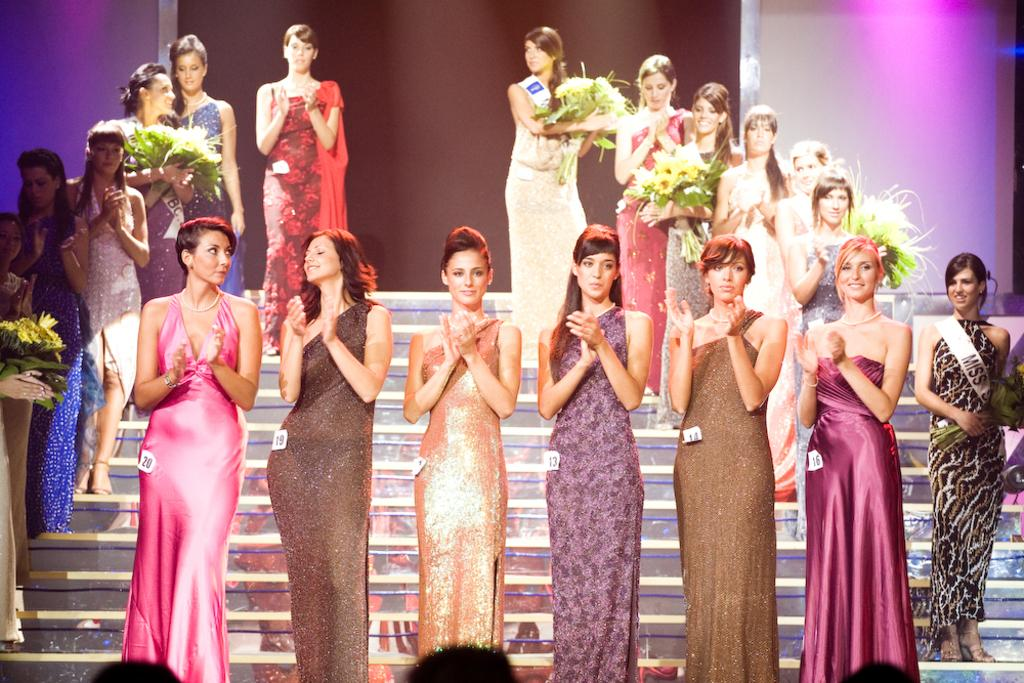Who or what can be seen in the image? There are people in the image. What are some of the people holding? Some people are holding flower bouquets. What architectural feature is present in the image? There are steps in the image. What can be seen in the background of the image? There is a wall in the background of the image. Can you see any blood on the people in the image? There is no blood visible on the people in the image. Are the people in the image friends? The image does not provide information about the relationships between the people, so we cannot determine if they are friends. 